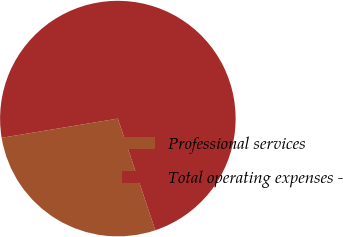<chart> <loc_0><loc_0><loc_500><loc_500><pie_chart><fcel>Professional services<fcel>Total operating expenses -<nl><fcel>27.54%<fcel>72.46%<nl></chart> 